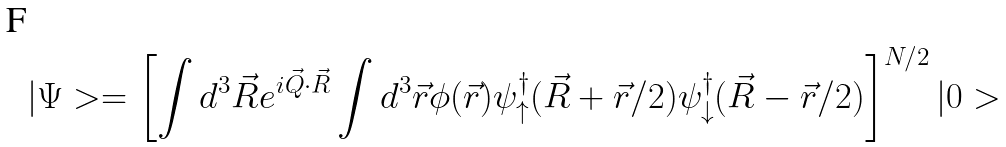<formula> <loc_0><loc_0><loc_500><loc_500>| \Psi > = \left [ \int d ^ { 3 } \vec { R } e ^ { i \vec { Q } \cdot \vec { R } } \int d ^ { 3 } \vec { r } \phi ( \vec { r } ) \psi ^ { \dagger } _ { \uparrow } ( \vec { R } + \vec { r } / 2 ) \psi ^ { \dagger } _ { \downarrow } ( \vec { R } - \vec { r } / 2 ) \right ] ^ { N / 2 } | 0 ></formula> 